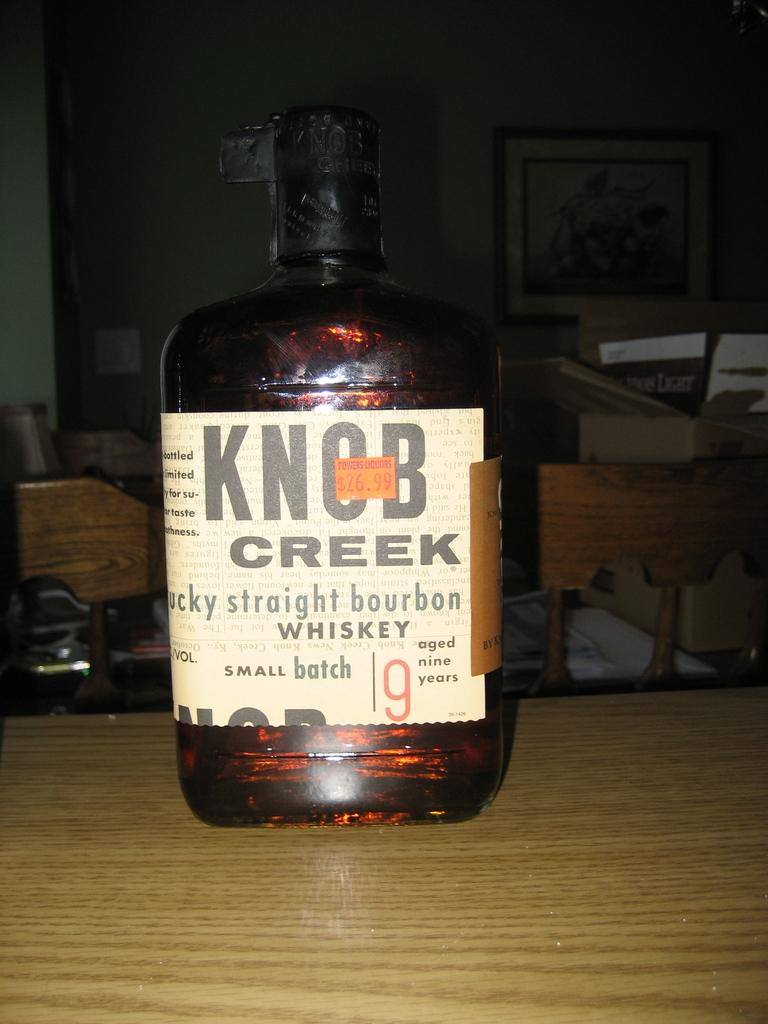<image>
Relay a brief, clear account of the picture shown. a bottle of kentucky straight bourbon whiskey called knob creek 